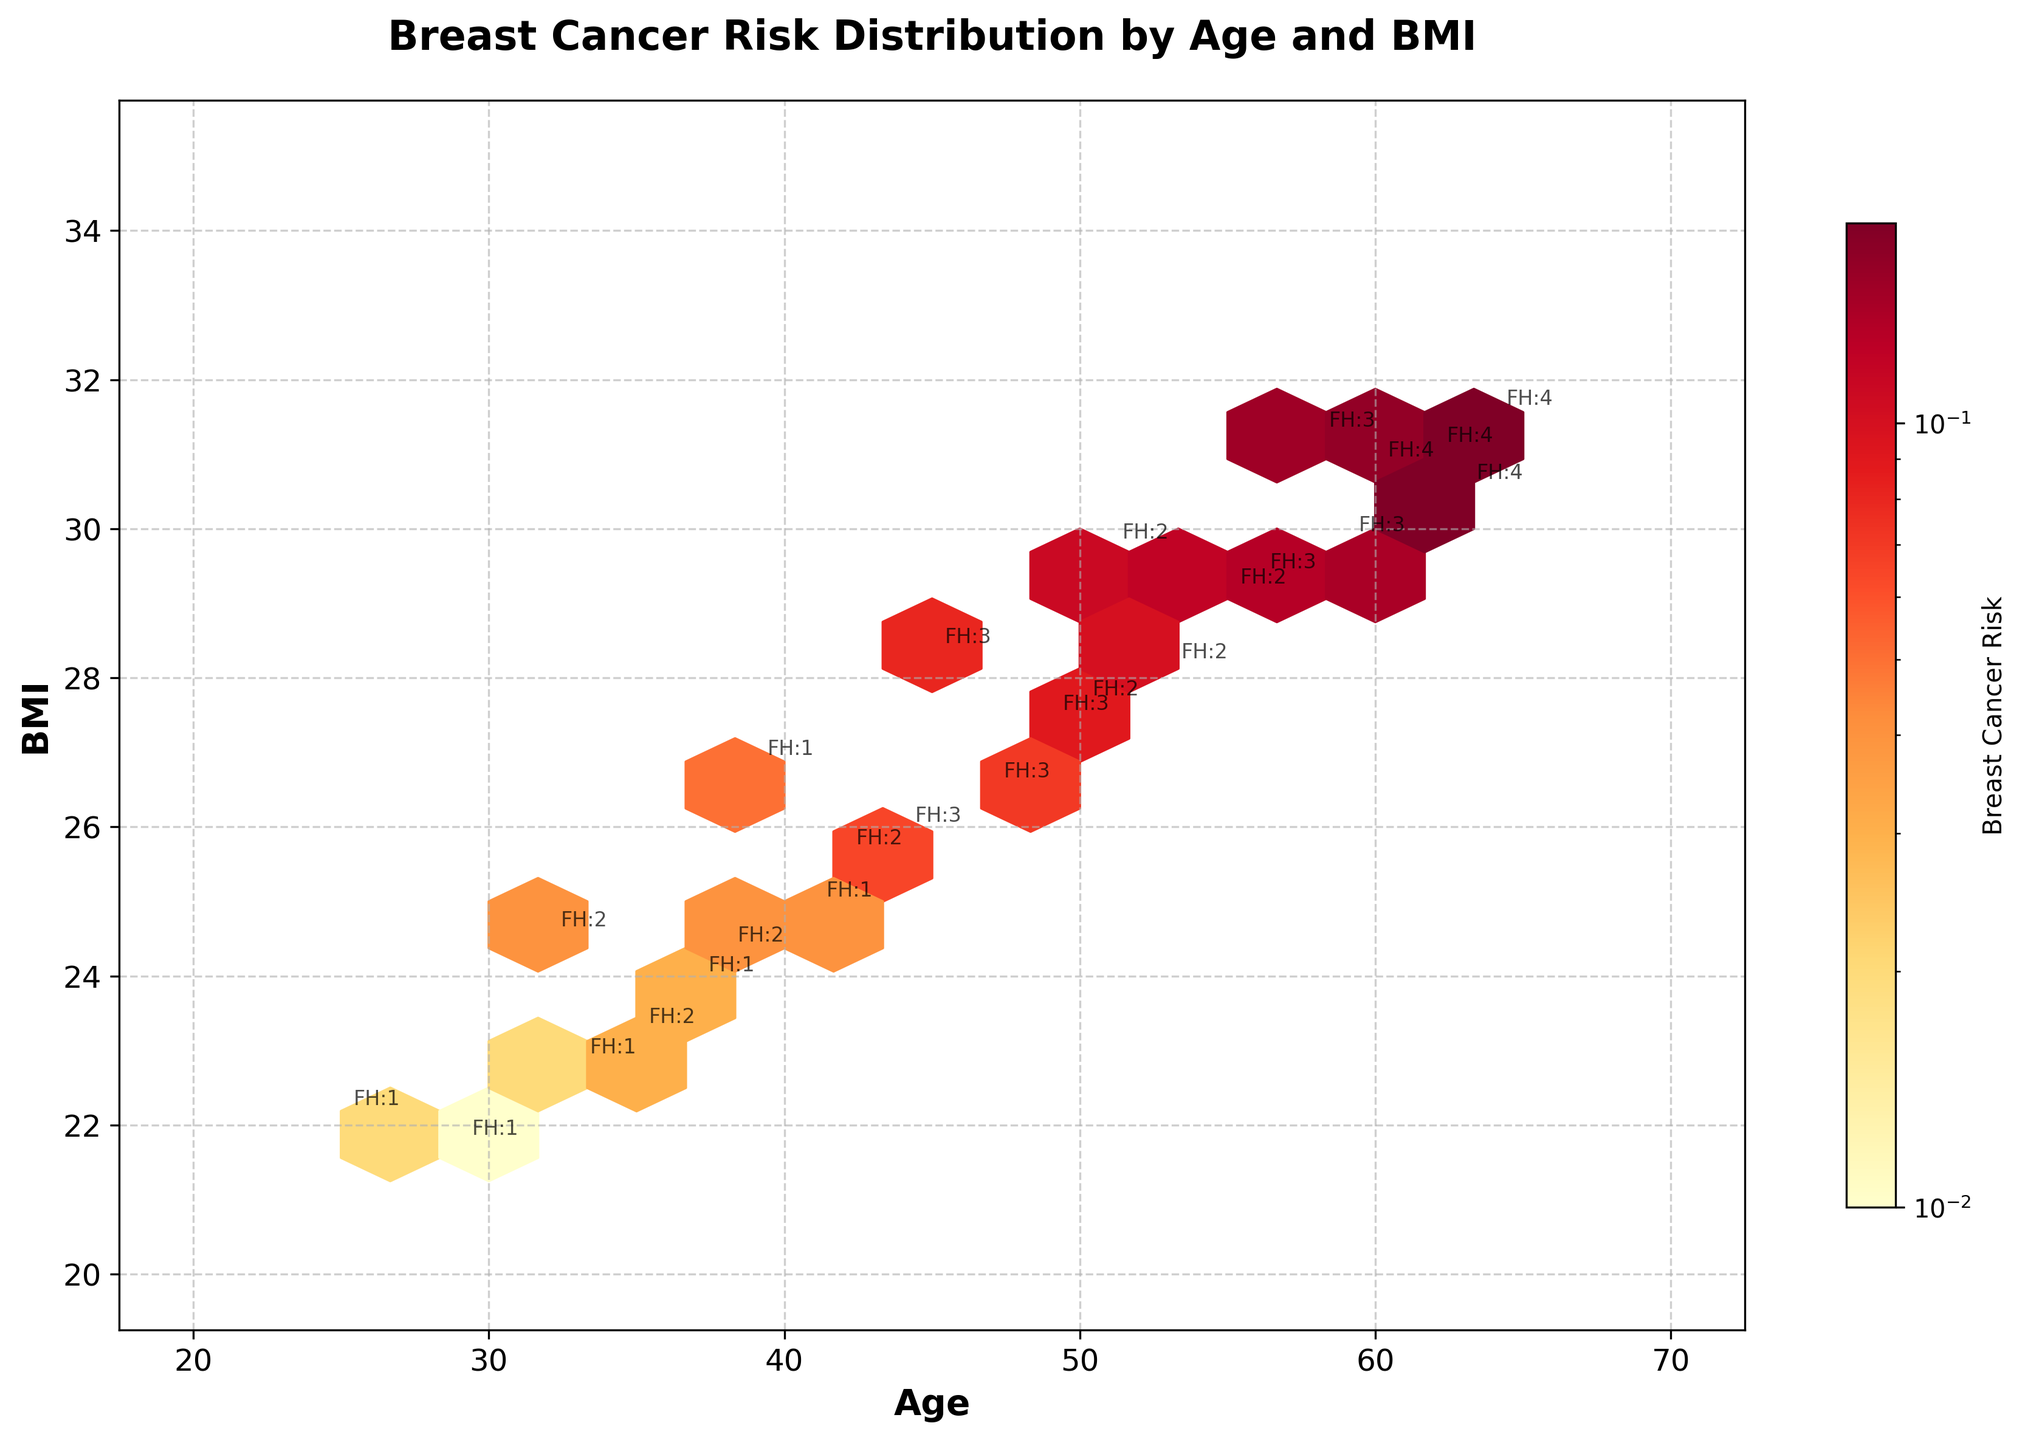What does the title of the figure signify? The title "Breast Cancer Risk Distribution by Age and BMI" indicates that the plot shows how breast cancer risk is distributed with respect to age and BMI.
Answer: Breast Cancer Risk Distribution by Age and BMI Which axis represents age? The x-axis represents age, as labeled with "Age."
Answer: x-axis How does the breast cancer risk vary in color in the plot? The color varies from lighter to darker shades, with darker shades indicating higher breast cancer risk levels. The color scale is shown in the color bar.
Answer: From lighter to darker shades What is the range of BMI values considered in the plot? The plot's y-axis ranges from 20 to 35, indicating the BMI values considered.
Answer: 20 to 35 How does the annotated "FH" information help in the plot? The "FH" annotations provide information on family history (with a number indicating the degree), making it easier to see the distribution of family history across the data points.
Answer: Indicates family history distribution What age group has the highest density of data points? By observing the hexbin's density, the age group around 50-60 appears to have the highest density of data points.
Answer: Around 50-60 Is there a general trend between BMI and breast cancer risk? The trend shows that as age and BMI increase, there is a corresponding increase in breast cancer risk. This is seen with the color intensity towards higher risk in older ages and higher BMI values.
Answer: Higher age and BMI correlate with higher risk How does the number of exercise hours per week compare among individuals aged 40 and above? Observing the annotated details, those aged 40 and above generally exercise between 1 to 3 hours per week.
Answer: Between 1 to 3 hours per week Where do you see the highest risk hexbin clusters, and what age and BMI ranges do they cover? The highest risk hexbin clusters are observed in the age range of 55-65 and BMI range of 28-32, as indicated by the darkest hexagons.
Answer: Age 55-65, BMI 28-32 What can be inferred about individuals with a family history of 4? Individuals with a family history rating of 4 appear in the higher age groups (around 60-64) and higher BMI ranges, suggesting higher breast cancer risk among them.
Answer: Higher risk, ages 60-64 